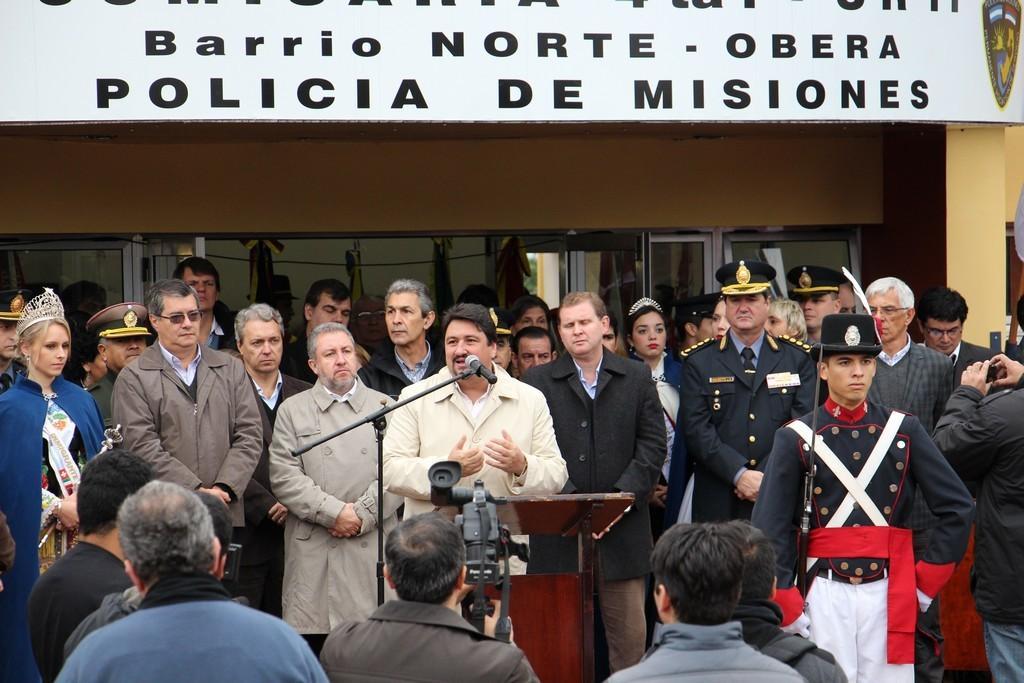Could you give a brief overview of what you see in this image? In the foreground I can see a group of people are standing on the floor, make, table and cameras. In the background I can see a wall, windows and a hoarding. This image is taken may be during a day. 